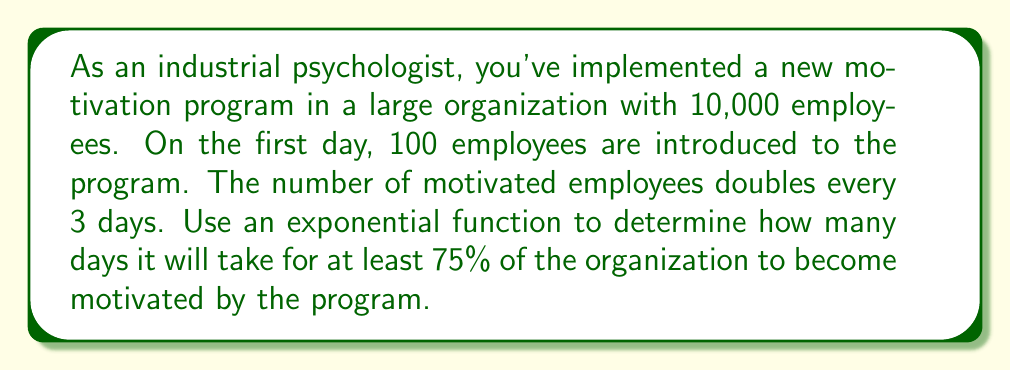Give your solution to this math problem. Let's approach this problem step-by-step:

1) First, we need to set up our exponential function. The general form is:

   $$ y = a \cdot b^x $$

   Where:
   $y$ = number of motivated employees
   $a$ = initial number of motivated employees (100)
   $b$ = growth factor
   $x$ = number of days

2) We know the number doubles every 3 days, so we can find $b$:

   $$ b^3 = 2 $$
   $$ b = \sqrt[3]{2} \approx 1.2599 $$

3) Our function is now:

   $$ y = 100 \cdot (1.2599)^{\frac{x}{3}} $$

4) We want to find when $y$ is at least 75% of 10,000, which is 7,500:

   $$ 7500 = 100 \cdot (1.2599)^{\frac{x}{3}} $$

5) Solve for $x$:

   $$ 75 = (1.2599)^{\frac{x}{3}} $$
   $$ \ln(75) = \frac{x}{3} \ln(1.2599) $$
   $$ x = 3 \cdot \frac{\ln(75)}{\ln(1.2599)} \approx 33.62 $$

6) Since we can't have a fractional day, we round up to the next whole number.
Answer: It will take 34 days for at least 75% of the organization to become motivated by the program. 